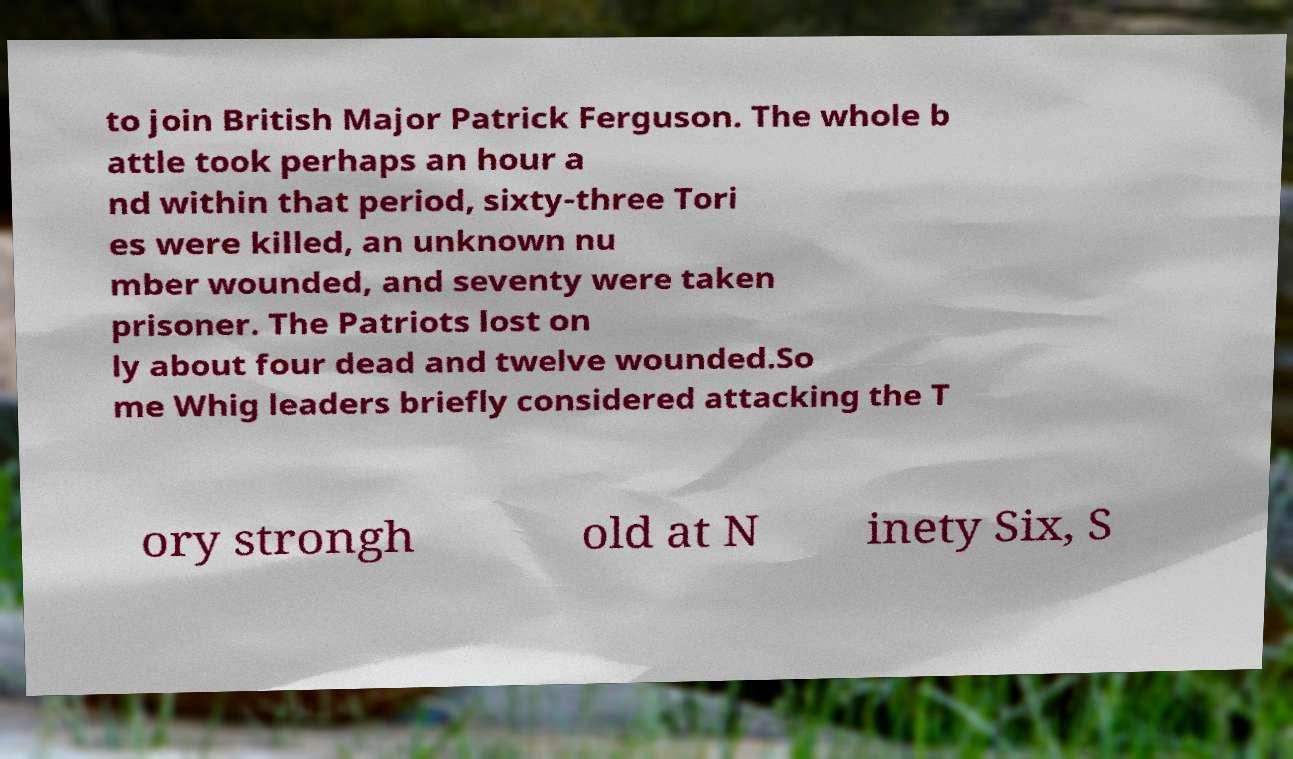Can you read and provide the text displayed in the image?This photo seems to have some interesting text. Can you extract and type it out for me? to join British Major Patrick Ferguson. The whole b attle took perhaps an hour a nd within that period, sixty-three Tori es were killed, an unknown nu mber wounded, and seventy were taken prisoner. The Patriots lost on ly about four dead and twelve wounded.So me Whig leaders briefly considered attacking the T ory strongh old at N inety Six, S 